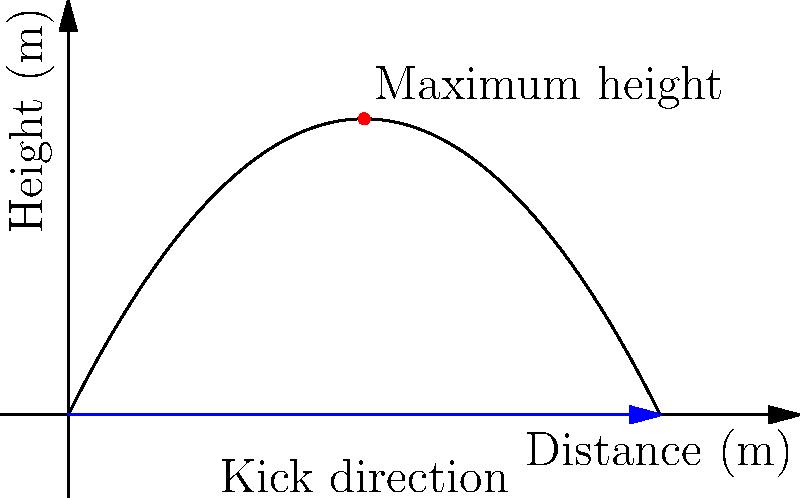In a crucial match between New Zealand and Fiji in the OFC Nations Cup, a New Zealand player needs to make a perfect kick to score. The trajectory of the ball can be modeled by the function $h(x) = -0.2x^2 + 2x$, where $h$ is the height in meters and $x$ is the horizontal distance in meters. What is the maximum height reached by the ball, and at what horizontal distance does this occur? To find the maximum height of the ball's trajectory and the corresponding horizontal distance, we need to follow these steps:

1) The function given is $h(x) = -0.2x^2 + 2x$, which is a parabola.

2) The maximum point of a parabola occurs at the vertex. For a parabola in the form $f(x) = ax^2 + bx + c$, the x-coordinate of the vertex is given by $x = -\frac{b}{2a}$.

3) In our case, $a = -0.2$ and $b = 2$. So:

   $x = -\frac{2}{2(-0.2)} = -\frac{2}{-0.4} = 5$ meters

4) To find the maximum height, we substitute this x-value back into the original function:

   $h(5) = -0.2(5)^2 + 2(5)$
   $    = -0.2(25) + 10$
   $    = -5 + 10 = 5$ meters

Therefore, the ball reaches its maximum height of 5 meters at a horizontal distance of 5 meters from the kick point.
Answer: Maximum height: 5 m, occurs at 5 m horizontally 